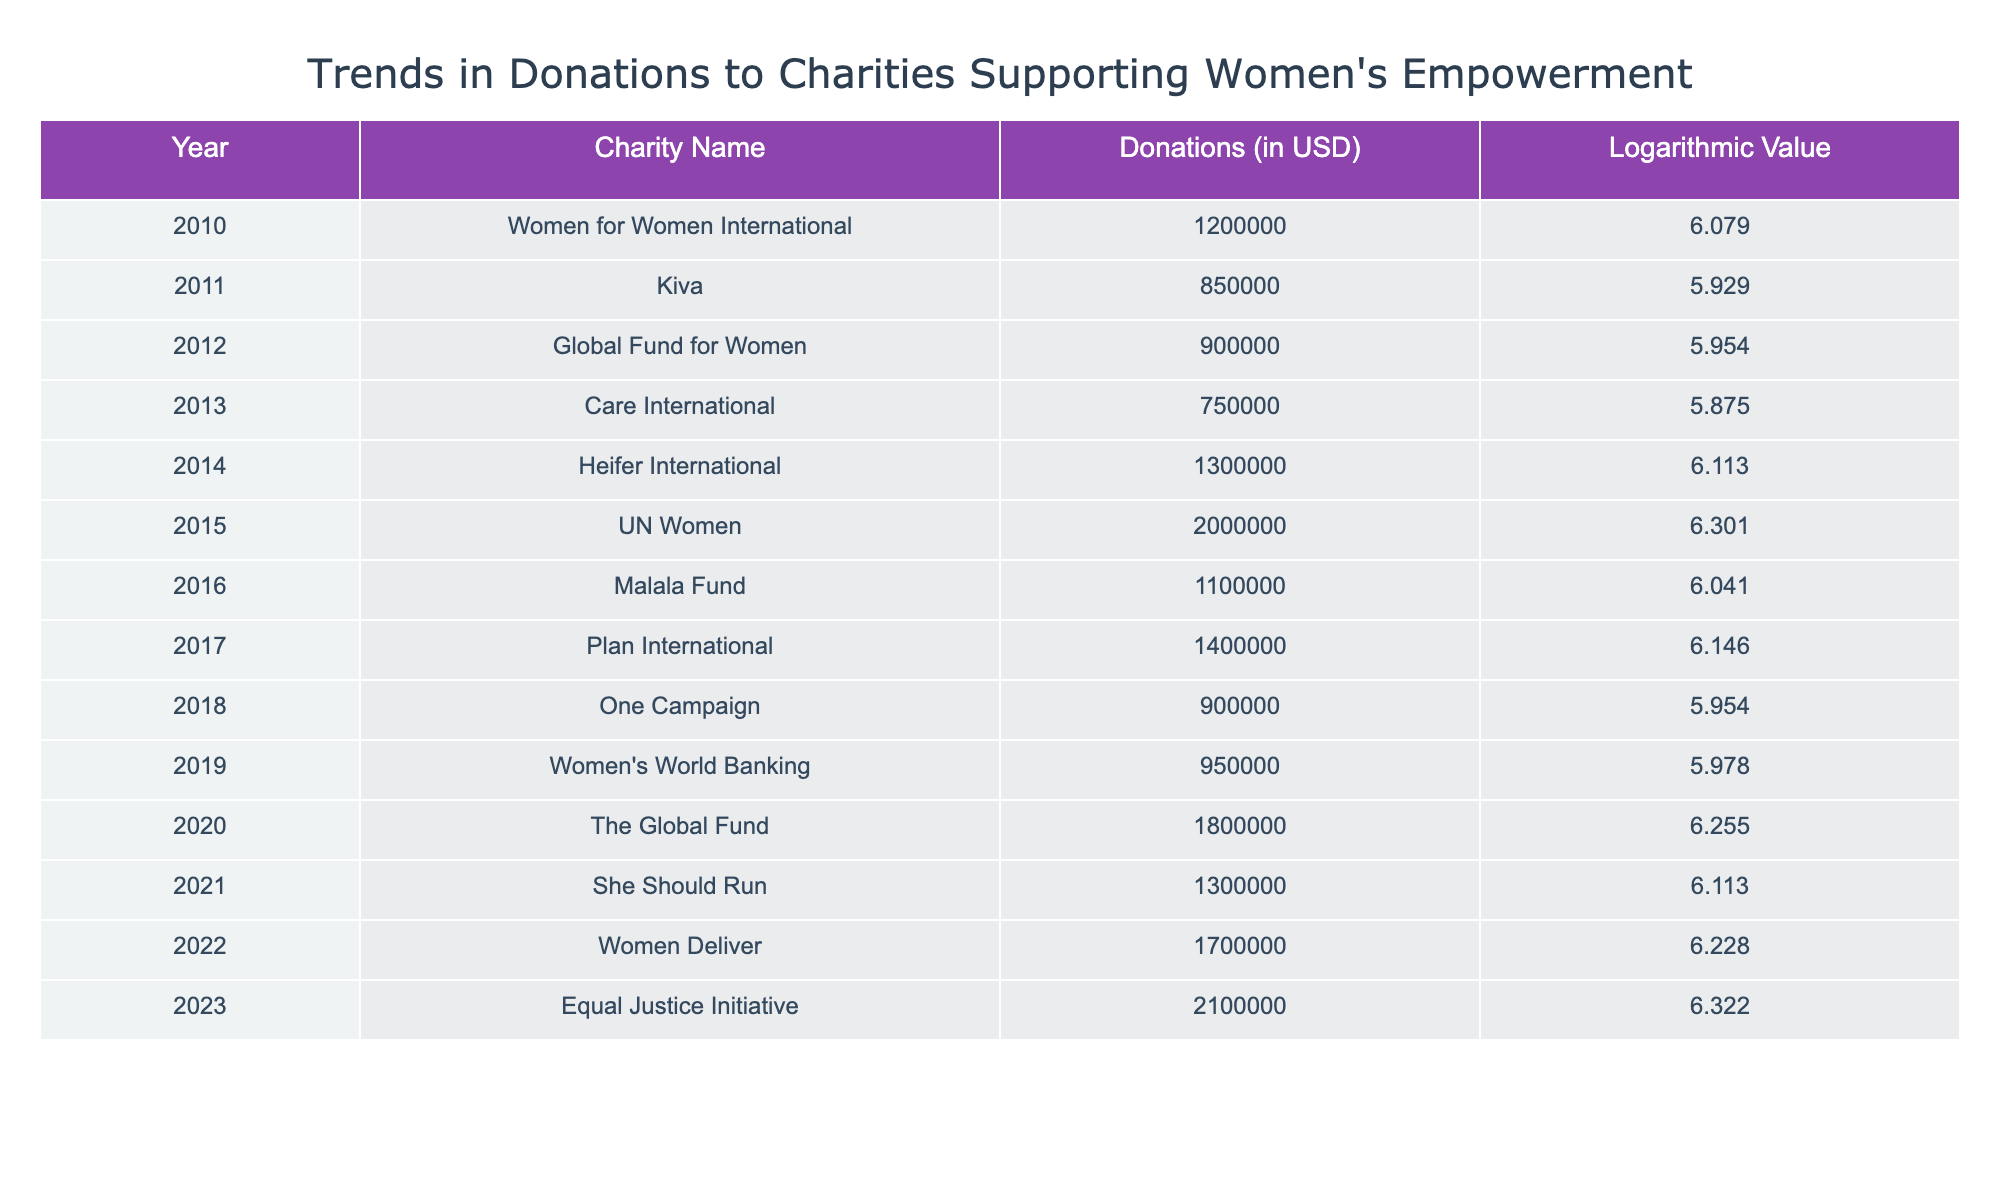What was the highest donation amount recorded in the table? The table shows various donation amounts for different years. Scanning through the "Donations (in USD)" column, the highest value is 2,100,000 in the year 2023 for the Equal Justice Initiative.
Answer: 2,100,000 Which charity received donations in the year 2015? In 2015, the charity that received donations was UN Women. This can be found by locating the row for that year in the "Charity Name" column.
Answer: UN Women What is the average donation amount from 2010 to 2023? To find the average, sum all the donation amounts: 1,200,000 + 850,000 + 900,000 + 750,000 + 1,300,000 + 2,000,000 + 1,100,000 + 1,400,000 + 900,000 + 950,000 + 1,800,000 + 1,300,000 + 1,700,000 + 2,100,000 = 16,800,000. Then, divide by the number of years (14), resulting in an average donation amount of 1,200,000.
Answer: 1,200,000 Did any charity surpass a donation of 2 million USD during these years? Yes, in 2015, donations from UN Women exceeded the 2 million USD mark as it reached 2,000,000. Additionally, in 2023, the Equal Justice Initiative surpassed this amount, reaching 2,100,000.
Answer: Yes Which year saw the smallest donation amount and what was it? Examining the donation amounts year by year, the smallest amount is 750,000, which was given to Care International in 2013. By reviewing each row, 2013 can be identified as the year with the lowest donation.
Answer: 2013, 750,000 What percentage increase in donations occurred from 2020 to 2021? To calculate the percentage increase, first find the donation amounts for those years: 2020 received 1,800,000 and 2021 received 1,300,000. The change in donations is (1,300,000 - 1,800,000), which equals -500,000. Then divide the change by the initial value (1,800,000): (-500,000 / 1,800,000) * 100 = -27.78%. Thus, this represents a decrease, not an increase.
Answer: -27.78% How many charities received more than 1 million USD in donations from 2010 to 2023? By reviewing the donations column, the charities that received more than 1 million USD are as follows: Women for Women International, Heifer International, UN Women, Plan International, The Global Fund, She Should Run, Women Deliver, and Equal Justice Initiative. Counting these, the total is 8 charities.
Answer: 8 In what year did the donations reach their minimum before exceeding 1 million USD for the first time? Reviewing the years, the first year that donations reached above 1 million USD is 2014 with Heifer International at 1,300,000. Prior to that, the donations remained below 1 million USD in 2010 (1,200,000) and 2011 (850,000) before the minimum. The year 2013 had the lowest at 750,000, and thus that year is identified.
Answer: 2013 